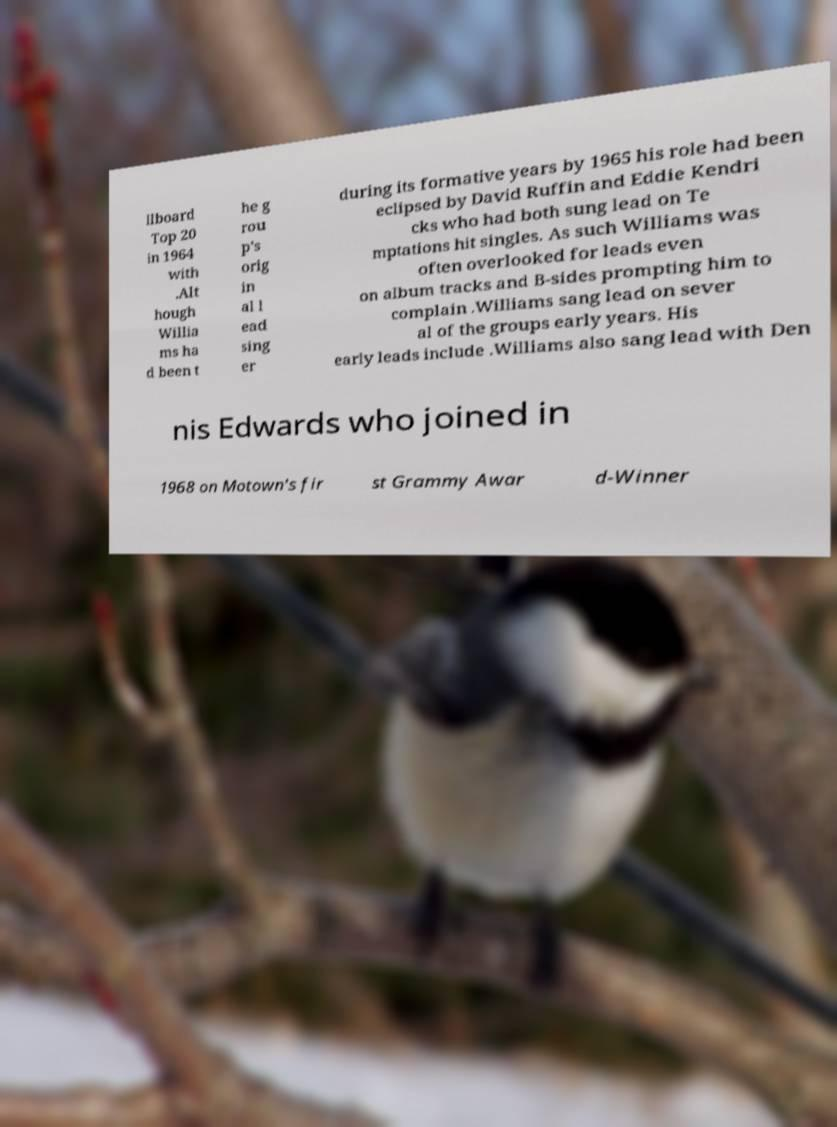Can you read and provide the text displayed in the image?This photo seems to have some interesting text. Can you extract and type it out for me? llboard Top 20 in 1964 with .Alt hough Willia ms ha d been t he g rou p's orig in al l ead sing er during its formative years by 1965 his role had been eclipsed by David Ruffin and Eddie Kendri cks who had both sung lead on Te mptations hit singles. As such Williams was often overlooked for leads even on album tracks and B-sides prompting him to complain .Williams sang lead on sever al of the groups early years. His early leads include .Williams also sang lead with Den nis Edwards who joined in 1968 on Motown's fir st Grammy Awar d-Winner 